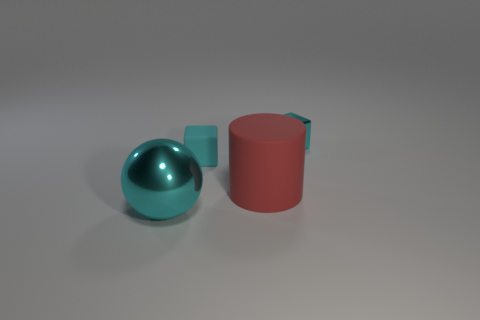There is a thing that is both to the left of the large rubber object and behind the large metal sphere; what color is it?
Provide a succinct answer. Cyan. Are there more cyan balls that are left of the big metal object than large red matte things?
Provide a short and direct response. No. Are any rubber objects visible?
Offer a very short reply. Yes. Is the color of the shiny block the same as the matte cube?
Provide a short and direct response. Yes. What number of large objects are either red objects or cyan metal objects?
Give a very brief answer. 2. Is there anything else that has the same color as the large shiny thing?
Make the answer very short. Yes. There is a small cyan thing that is made of the same material as the red object; what is its shape?
Give a very brief answer. Cube. There is a cyan shiny object that is to the right of the big metal sphere; what is its size?
Keep it short and to the point. Small. What is the shape of the big cyan object?
Make the answer very short. Sphere. There is a cyan metallic thing to the right of the tiny rubber thing; is it the same size as the sphere that is to the left of the big matte cylinder?
Offer a very short reply. No. 